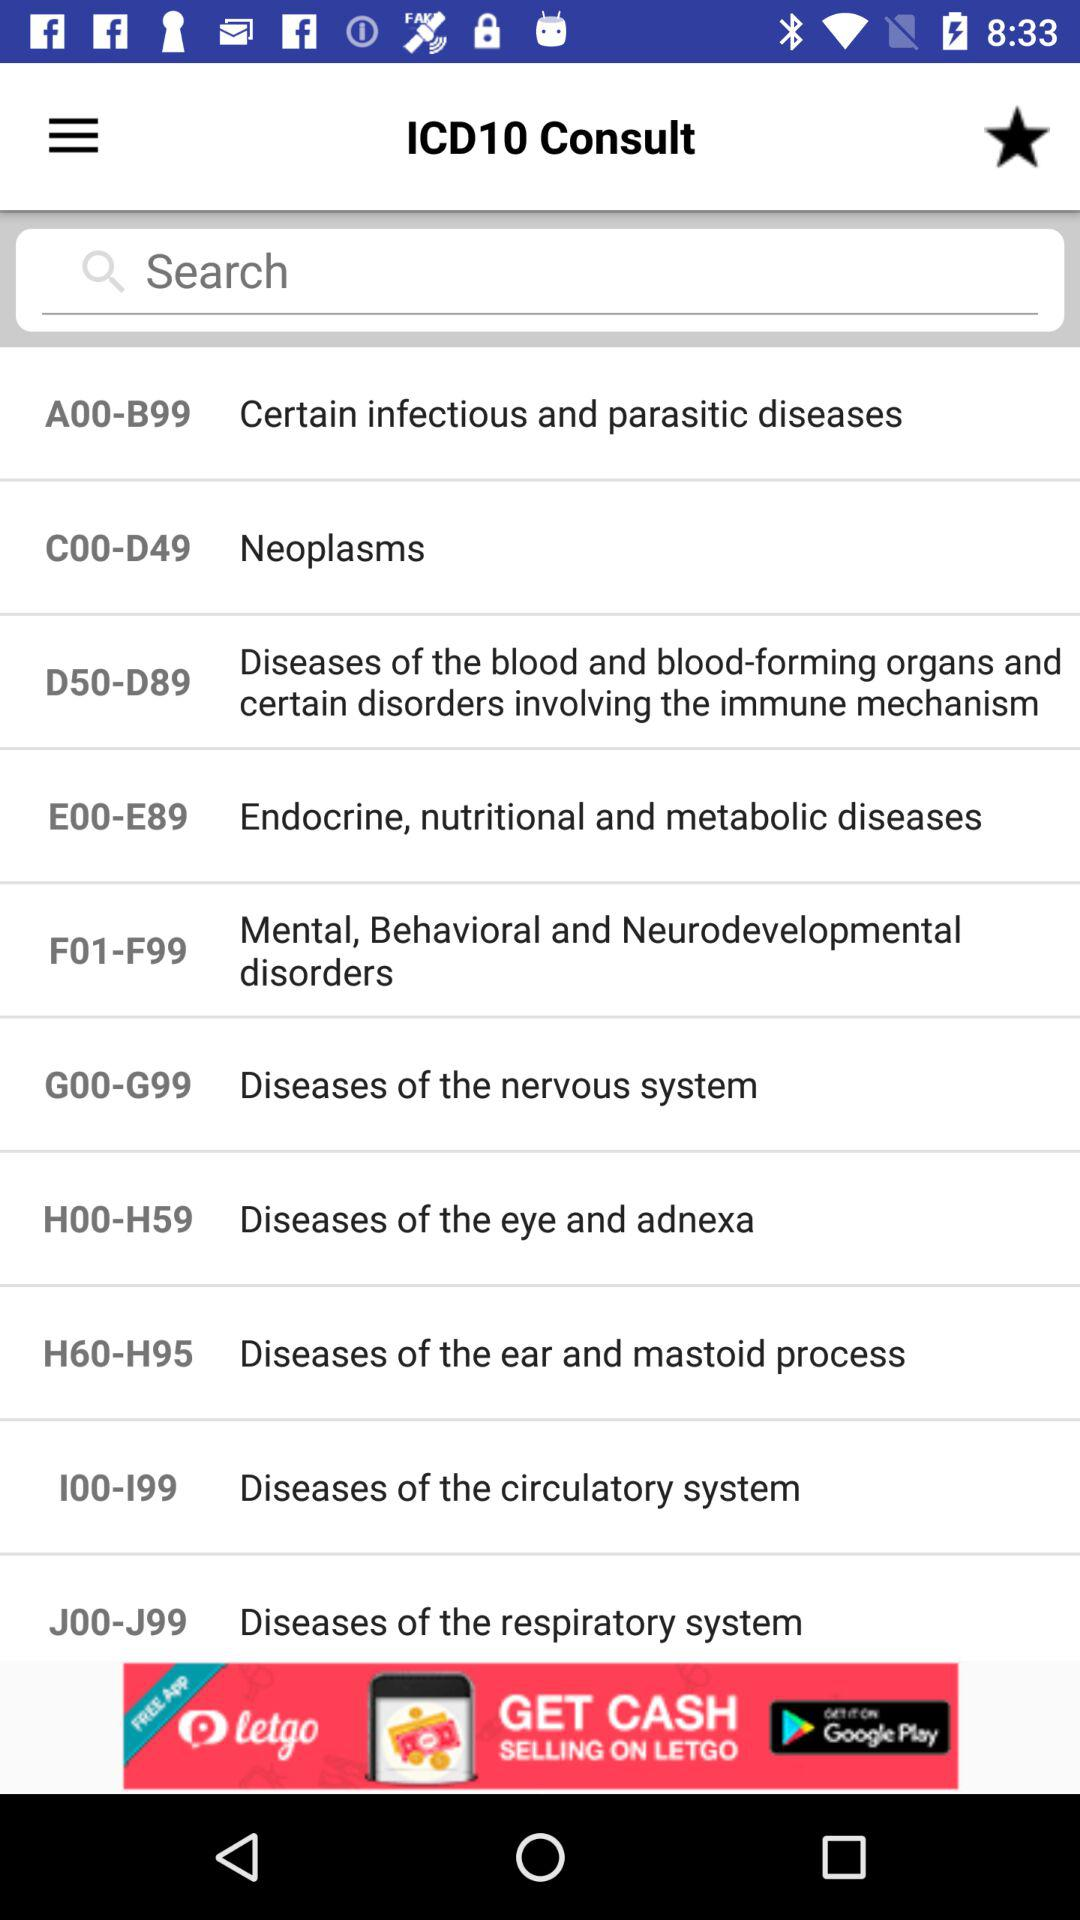What is the name of the application? The application name is "ICD10 Consult". 